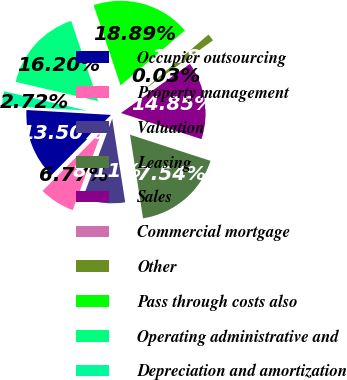Convert chart. <chart><loc_0><loc_0><loc_500><loc_500><pie_chart><fcel>Occupier outsourcing<fcel>Property management<fcel>Valuation<fcel>Leasing<fcel>Sales<fcel>Commercial mortgage<fcel>Other<fcel>Pass through costs also<fcel>Operating administrative and<fcel>Depreciation and amortization<nl><fcel>13.5%<fcel>6.77%<fcel>8.11%<fcel>17.54%<fcel>14.85%<fcel>0.03%<fcel>1.38%<fcel>18.89%<fcel>16.2%<fcel>2.72%<nl></chart> 